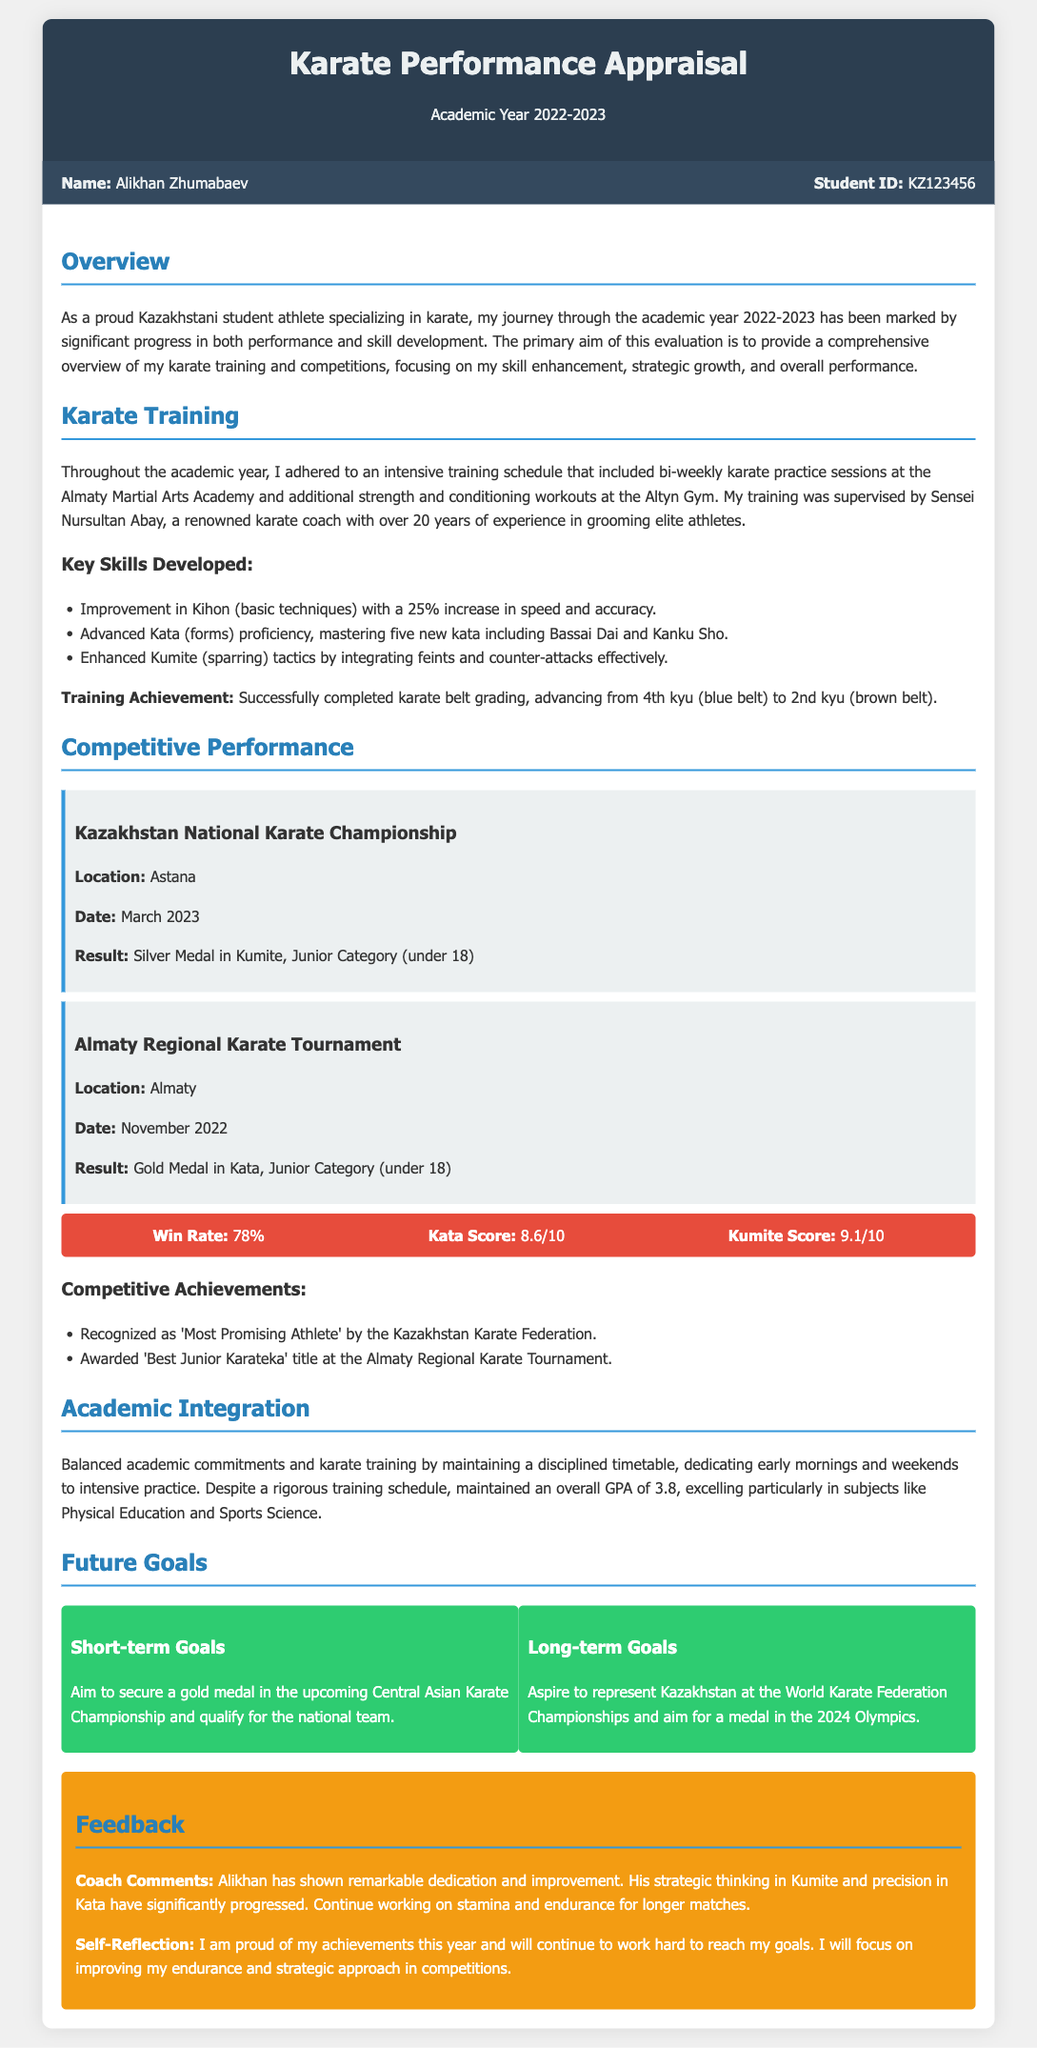What is the name of the student? The name of the student is mentioned in the student info section of the document.
Answer: Alikhan Zhumabaev What was the result at the Kazakhstan National Karate Championship? The result is specified in the Competitive Performance section of the document.
Answer: Silver Medal in Kumite, Junior Category (under 18) When did the Almaty Regional Karate Tournament take place? The date of the tournament is included in the Competitive Performance section.
Answer: November 2022 What belt level did the student achieve by the end of the academic year? The training achievement section provides information on the student's belt progression.
Answer: 2nd kyu (brown belt) Which kata did the student master this year? This information can be found under Key Skills Developed in the Karate Training section.
Answer: Bassai Dai and Kanku Sho What is the overall GPA maintained by the student? The GPA is stated in the Academic Integration section of the document.
Answer: 3.8 What is one of the student's short-term goals? This information is provided in the Future Goals section, specifically under Short-term Goals.
Answer: Secure a gold medal in the upcoming Central Asian Karate Championship Who is the student's supervisor? The name of the supervisor is mentioned in the Karate Training section.
Answer: Sensei Nursultan Abay What score did the student achieve in Kumite? The score appears in the metrics section of the Competitive Performance part.
Answer: 9.1/10 